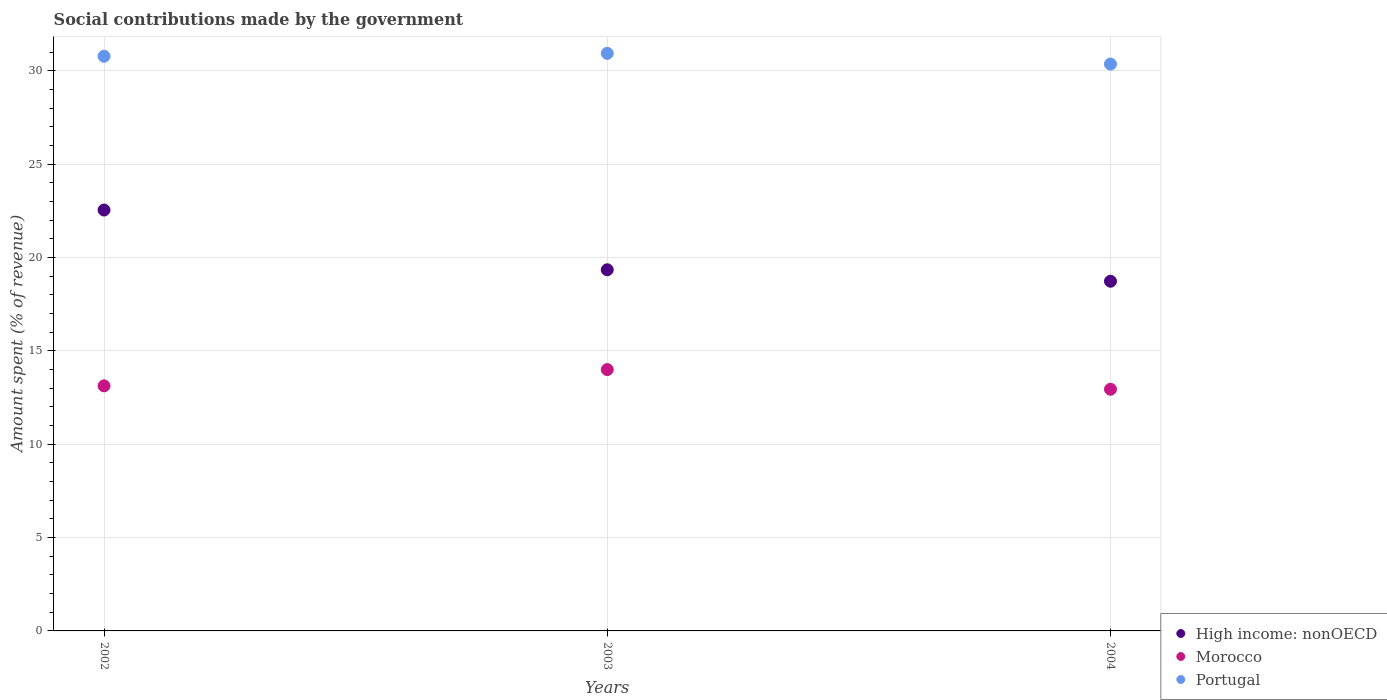How many different coloured dotlines are there?
Your answer should be very brief. 3. What is the amount spent (in %) on social contributions in High income: nonOECD in 2002?
Make the answer very short. 22.55. Across all years, what is the maximum amount spent (in %) on social contributions in Portugal?
Your response must be concise. 30.94. Across all years, what is the minimum amount spent (in %) on social contributions in Portugal?
Offer a very short reply. 30.37. In which year was the amount spent (in %) on social contributions in Morocco maximum?
Offer a terse response. 2003. What is the total amount spent (in %) on social contributions in Morocco in the graph?
Provide a succinct answer. 40.08. What is the difference between the amount spent (in %) on social contributions in High income: nonOECD in 2002 and that in 2004?
Your response must be concise. 3.81. What is the difference between the amount spent (in %) on social contributions in High income: nonOECD in 2002 and the amount spent (in %) on social contributions in Portugal in 2003?
Make the answer very short. -8.39. What is the average amount spent (in %) on social contributions in Portugal per year?
Your answer should be very brief. 30.7. In the year 2002, what is the difference between the amount spent (in %) on social contributions in Portugal and amount spent (in %) on social contributions in Morocco?
Provide a succinct answer. 17.66. In how many years, is the amount spent (in %) on social contributions in High income: nonOECD greater than 30 %?
Provide a short and direct response. 0. What is the ratio of the amount spent (in %) on social contributions in Portugal in 2002 to that in 2003?
Offer a terse response. 0.99. Is the amount spent (in %) on social contributions in Portugal in 2002 less than that in 2004?
Offer a very short reply. No. What is the difference between the highest and the second highest amount spent (in %) on social contributions in High income: nonOECD?
Provide a succinct answer. 3.2. What is the difference between the highest and the lowest amount spent (in %) on social contributions in Morocco?
Provide a succinct answer. 1.05. In how many years, is the amount spent (in %) on social contributions in Morocco greater than the average amount spent (in %) on social contributions in Morocco taken over all years?
Offer a terse response. 1. Is the amount spent (in %) on social contributions in High income: nonOECD strictly less than the amount spent (in %) on social contributions in Morocco over the years?
Ensure brevity in your answer.  No. How many dotlines are there?
Your answer should be compact. 3. Does the graph contain any zero values?
Keep it short and to the point. No. Does the graph contain grids?
Make the answer very short. Yes. What is the title of the graph?
Offer a terse response. Social contributions made by the government. What is the label or title of the X-axis?
Make the answer very short. Years. What is the label or title of the Y-axis?
Offer a very short reply. Amount spent (% of revenue). What is the Amount spent (% of revenue) of High income: nonOECD in 2002?
Offer a terse response. 22.55. What is the Amount spent (% of revenue) in Morocco in 2002?
Provide a short and direct response. 13.13. What is the Amount spent (% of revenue) of Portugal in 2002?
Provide a short and direct response. 30.79. What is the Amount spent (% of revenue) in High income: nonOECD in 2003?
Keep it short and to the point. 19.35. What is the Amount spent (% of revenue) in Morocco in 2003?
Your answer should be very brief. 14. What is the Amount spent (% of revenue) of Portugal in 2003?
Ensure brevity in your answer.  30.94. What is the Amount spent (% of revenue) in High income: nonOECD in 2004?
Provide a succinct answer. 18.74. What is the Amount spent (% of revenue) of Morocco in 2004?
Your response must be concise. 12.95. What is the Amount spent (% of revenue) in Portugal in 2004?
Provide a short and direct response. 30.37. Across all years, what is the maximum Amount spent (% of revenue) of High income: nonOECD?
Give a very brief answer. 22.55. Across all years, what is the maximum Amount spent (% of revenue) of Morocco?
Ensure brevity in your answer.  14. Across all years, what is the maximum Amount spent (% of revenue) in Portugal?
Give a very brief answer. 30.94. Across all years, what is the minimum Amount spent (% of revenue) of High income: nonOECD?
Offer a terse response. 18.74. Across all years, what is the minimum Amount spent (% of revenue) in Morocco?
Ensure brevity in your answer.  12.95. Across all years, what is the minimum Amount spent (% of revenue) in Portugal?
Your answer should be very brief. 30.37. What is the total Amount spent (% of revenue) in High income: nonOECD in the graph?
Offer a terse response. 60.64. What is the total Amount spent (% of revenue) of Morocco in the graph?
Your answer should be compact. 40.08. What is the total Amount spent (% of revenue) in Portugal in the graph?
Provide a succinct answer. 92.1. What is the difference between the Amount spent (% of revenue) in High income: nonOECD in 2002 and that in 2003?
Provide a short and direct response. 3.2. What is the difference between the Amount spent (% of revenue) in Morocco in 2002 and that in 2003?
Provide a short and direct response. -0.87. What is the difference between the Amount spent (% of revenue) of Portugal in 2002 and that in 2003?
Give a very brief answer. -0.16. What is the difference between the Amount spent (% of revenue) of High income: nonOECD in 2002 and that in 2004?
Ensure brevity in your answer.  3.81. What is the difference between the Amount spent (% of revenue) in Morocco in 2002 and that in 2004?
Ensure brevity in your answer.  0.18. What is the difference between the Amount spent (% of revenue) in Portugal in 2002 and that in 2004?
Your answer should be compact. 0.42. What is the difference between the Amount spent (% of revenue) of High income: nonOECD in 2003 and that in 2004?
Your response must be concise. 0.61. What is the difference between the Amount spent (% of revenue) of Morocco in 2003 and that in 2004?
Give a very brief answer. 1.05. What is the difference between the Amount spent (% of revenue) in Portugal in 2003 and that in 2004?
Ensure brevity in your answer.  0.57. What is the difference between the Amount spent (% of revenue) in High income: nonOECD in 2002 and the Amount spent (% of revenue) in Morocco in 2003?
Provide a short and direct response. 8.55. What is the difference between the Amount spent (% of revenue) of High income: nonOECD in 2002 and the Amount spent (% of revenue) of Portugal in 2003?
Keep it short and to the point. -8.39. What is the difference between the Amount spent (% of revenue) in Morocco in 2002 and the Amount spent (% of revenue) in Portugal in 2003?
Keep it short and to the point. -17.81. What is the difference between the Amount spent (% of revenue) of High income: nonOECD in 2002 and the Amount spent (% of revenue) of Morocco in 2004?
Give a very brief answer. 9.6. What is the difference between the Amount spent (% of revenue) of High income: nonOECD in 2002 and the Amount spent (% of revenue) of Portugal in 2004?
Your answer should be very brief. -7.82. What is the difference between the Amount spent (% of revenue) in Morocco in 2002 and the Amount spent (% of revenue) in Portugal in 2004?
Give a very brief answer. -17.24. What is the difference between the Amount spent (% of revenue) in High income: nonOECD in 2003 and the Amount spent (% of revenue) in Morocco in 2004?
Keep it short and to the point. 6.4. What is the difference between the Amount spent (% of revenue) of High income: nonOECD in 2003 and the Amount spent (% of revenue) of Portugal in 2004?
Provide a short and direct response. -11.02. What is the difference between the Amount spent (% of revenue) of Morocco in 2003 and the Amount spent (% of revenue) of Portugal in 2004?
Your answer should be very brief. -16.37. What is the average Amount spent (% of revenue) in High income: nonOECD per year?
Give a very brief answer. 20.21. What is the average Amount spent (% of revenue) in Morocco per year?
Offer a terse response. 13.36. What is the average Amount spent (% of revenue) in Portugal per year?
Keep it short and to the point. 30.7. In the year 2002, what is the difference between the Amount spent (% of revenue) of High income: nonOECD and Amount spent (% of revenue) of Morocco?
Offer a terse response. 9.42. In the year 2002, what is the difference between the Amount spent (% of revenue) of High income: nonOECD and Amount spent (% of revenue) of Portugal?
Offer a terse response. -8.24. In the year 2002, what is the difference between the Amount spent (% of revenue) in Morocco and Amount spent (% of revenue) in Portugal?
Your answer should be compact. -17.66. In the year 2003, what is the difference between the Amount spent (% of revenue) of High income: nonOECD and Amount spent (% of revenue) of Morocco?
Offer a terse response. 5.35. In the year 2003, what is the difference between the Amount spent (% of revenue) of High income: nonOECD and Amount spent (% of revenue) of Portugal?
Offer a terse response. -11.59. In the year 2003, what is the difference between the Amount spent (% of revenue) of Morocco and Amount spent (% of revenue) of Portugal?
Ensure brevity in your answer.  -16.94. In the year 2004, what is the difference between the Amount spent (% of revenue) in High income: nonOECD and Amount spent (% of revenue) in Morocco?
Make the answer very short. 5.79. In the year 2004, what is the difference between the Amount spent (% of revenue) in High income: nonOECD and Amount spent (% of revenue) in Portugal?
Offer a very short reply. -11.64. In the year 2004, what is the difference between the Amount spent (% of revenue) in Morocco and Amount spent (% of revenue) in Portugal?
Ensure brevity in your answer.  -17.42. What is the ratio of the Amount spent (% of revenue) of High income: nonOECD in 2002 to that in 2003?
Keep it short and to the point. 1.17. What is the ratio of the Amount spent (% of revenue) of Morocco in 2002 to that in 2003?
Ensure brevity in your answer.  0.94. What is the ratio of the Amount spent (% of revenue) in High income: nonOECD in 2002 to that in 2004?
Offer a terse response. 1.2. What is the ratio of the Amount spent (% of revenue) of Morocco in 2002 to that in 2004?
Provide a succinct answer. 1.01. What is the ratio of the Amount spent (% of revenue) in Portugal in 2002 to that in 2004?
Make the answer very short. 1.01. What is the ratio of the Amount spent (% of revenue) in High income: nonOECD in 2003 to that in 2004?
Your response must be concise. 1.03. What is the ratio of the Amount spent (% of revenue) in Morocco in 2003 to that in 2004?
Offer a terse response. 1.08. What is the ratio of the Amount spent (% of revenue) in Portugal in 2003 to that in 2004?
Offer a very short reply. 1.02. What is the difference between the highest and the second highest Amount spent (% of revenue) of High income: nonOECD?
Your answer should be very brief. 3.2. What is the difference between the highest and the second highest Amount spent (% of revenue) of Morocco?
Give a very brief answer. 0.87. What is the difference between the highest and the second highest Amount spent (% of revenue) in Portugal?
Make the answer very short. 0.16. What is the difference between the highest and the lowest Amount spent (% of revenue) of High income: nonOECD?
Offer a terse response. 3.81. What is the difference between the highest and the lowest Amount spent (% of revenue) of Morocco?
Offer a very short reply. 1.05. What is the difference between the highest and the lowest Amount spent (% of revenue) in Portugal?
Offer a terse response. 0.57. 